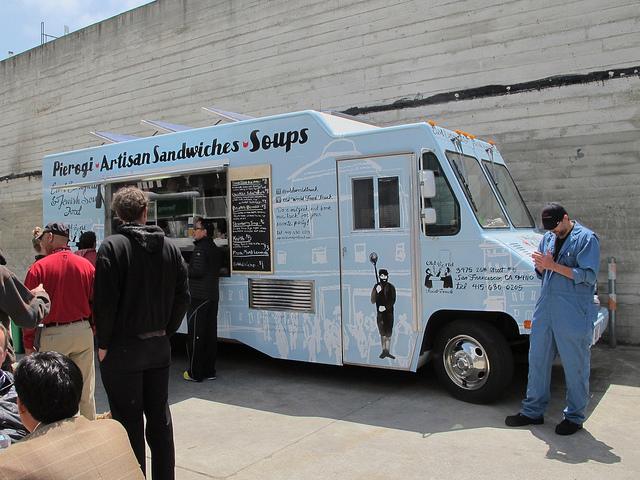What is the man in blue doing?
Keep it brief. Praying. Is this a greyhound?
Quick response, please. No. Does it appear to be a cold day?
Keep it brief. No. Is this a popular food truck?
Answer briefly. Yes. What type of socks is the man wearing on the right?
Quick response, please. Black. What is the ground made of?
Answer briefly. Concrete. Is there a basketball hoop?
Keep it brief. No. Is there an animal in the truck?
Concise answer only. No. 